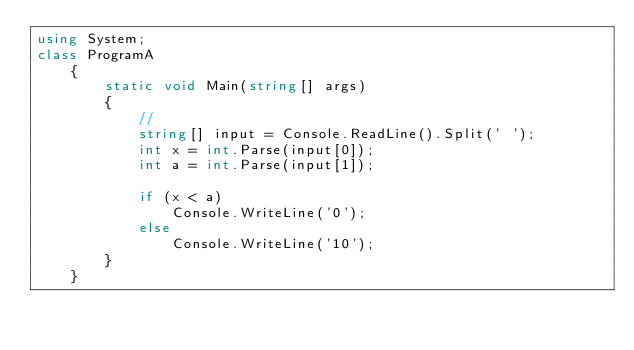<code> <loc_0><loc_0><loc_500><loc_500><_C#_>using System;
class ProgramA
    {
        static void Main(string[] args)
        {
            //
            string[] input = Console.ReadLine().Split(' ');
            int x = int.Parse(input[0]);
            int a = int.Parse(input[1]);

            if (x < a)
                Console.WriteLine('0');
            else
                Console.WriteLine('10');
        }
    }</code> 